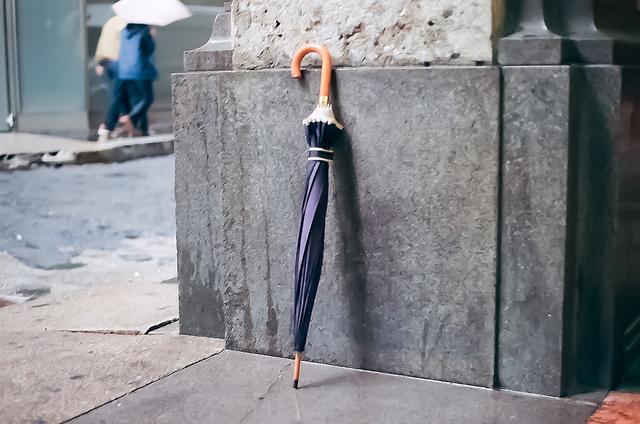What color is the handle of the umbrella?
Answer briefly. Tan. Where is the umbrella?
Answer briefly. Against wall. How many umbrellas do you see?
Give a very brief answer. 1. 